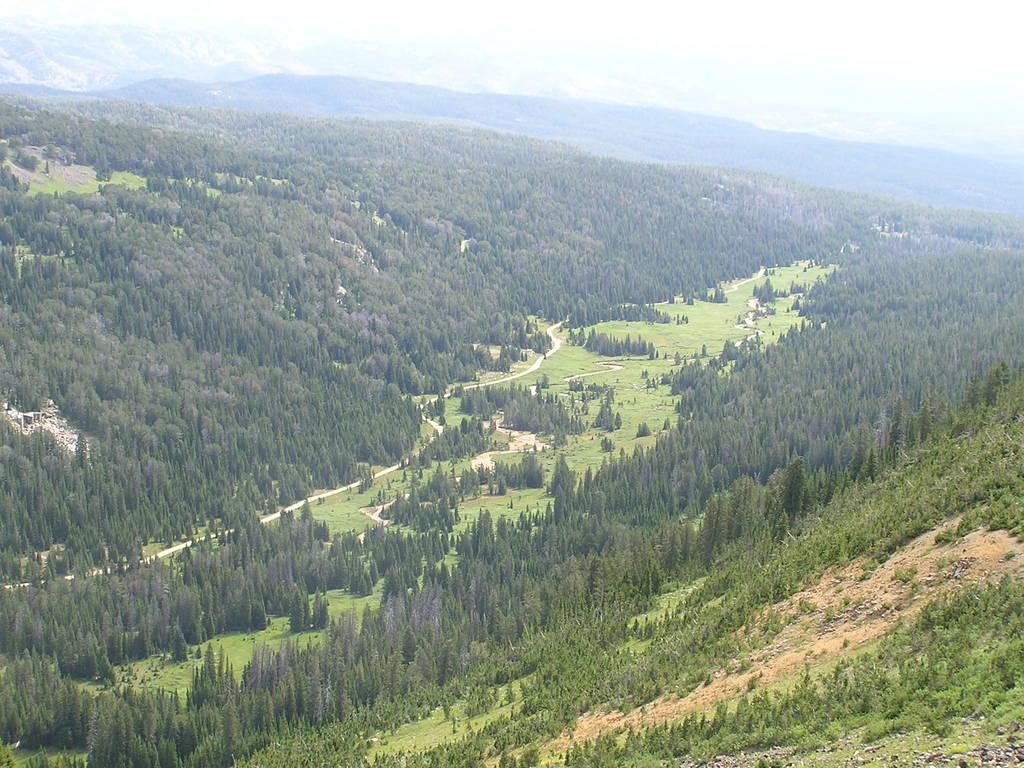What type of vegetation covers the ground in the image? The ground is covered with trees in the image. Is there any other type of vegetation present between the trees? Yes, there is an area with grass between the trees. What type of natural environment is depicted in the image? The area is a forest. What type of bell can be heard ringing in the forest during a rainstorm? There is no bell or rainstorm present in the image, so it is not possible to answer that question. 